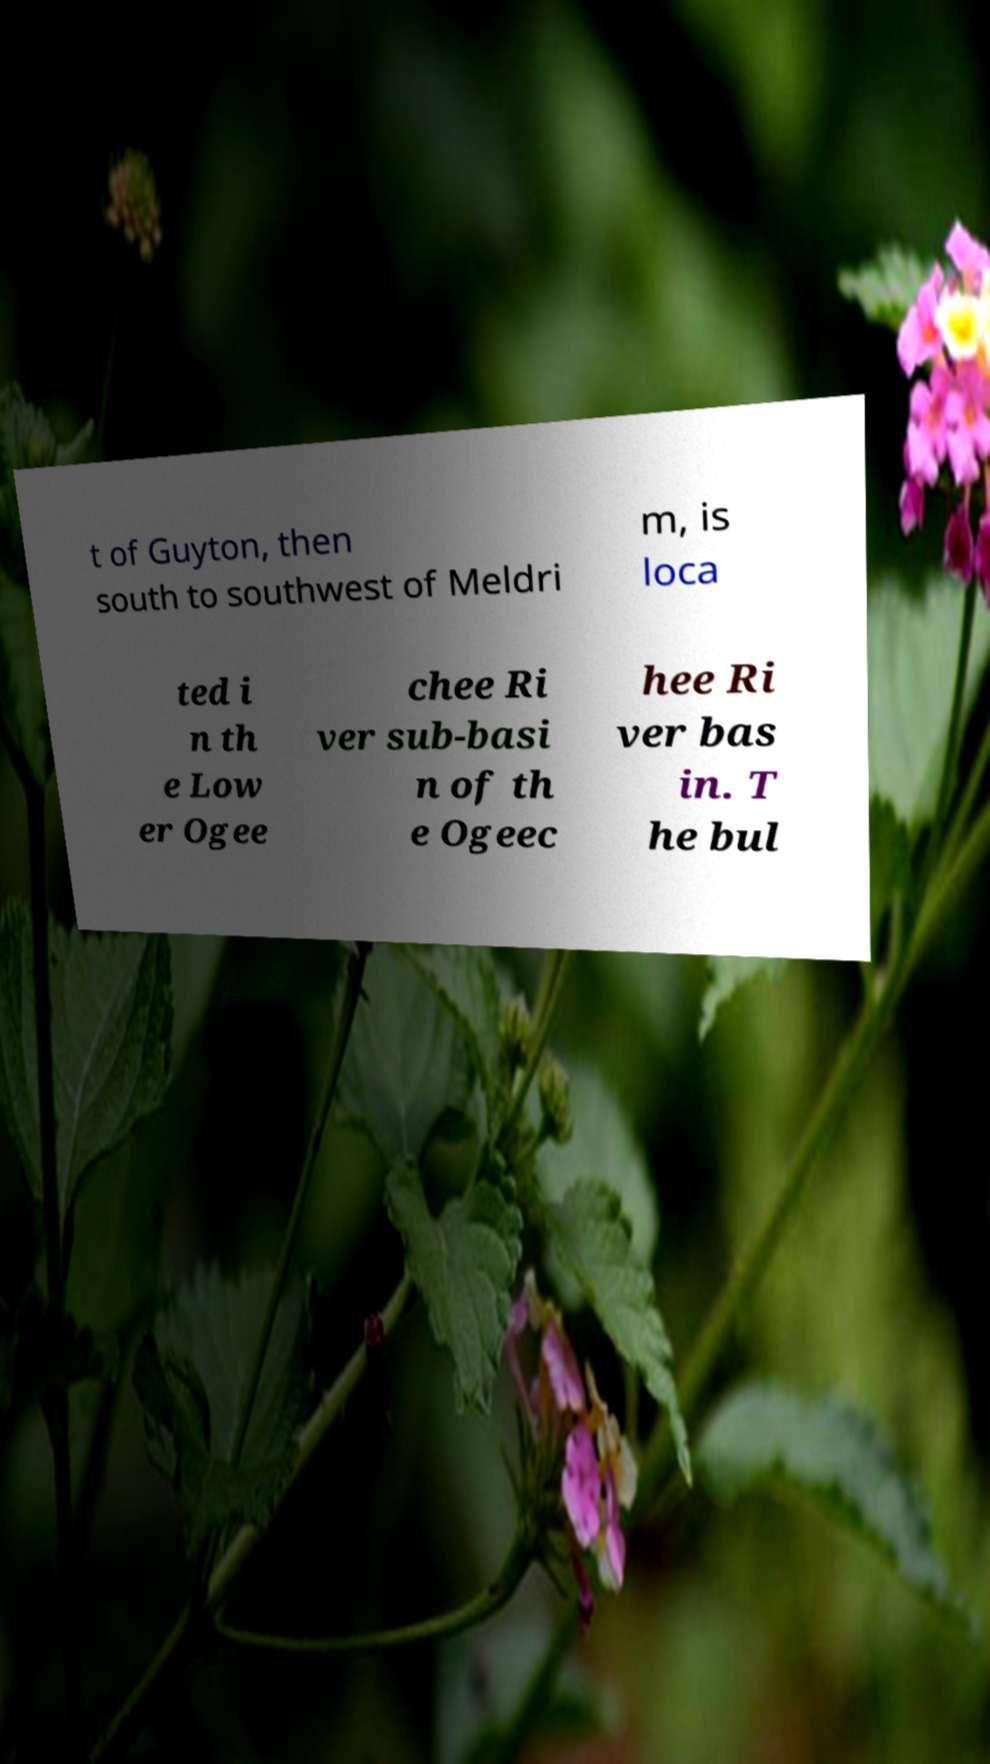Could you extract and type out the text from this image? t of Guyton, then south to southwest of Meldri m, is loca ted i n th e Low er Ogee chee Ri ver sub-basi n of th e Ogeec hee Ri ver bas in. T he bul 